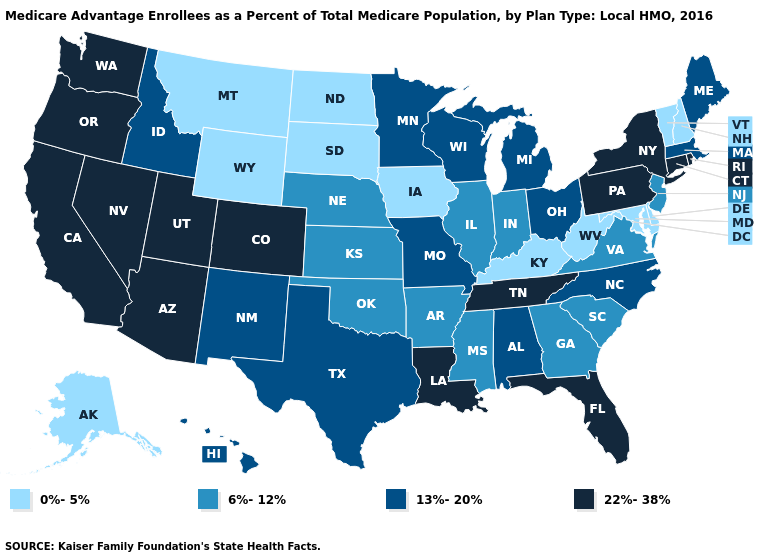What is the value of Virginia?
Concise answer only. 6%-12%. What is the highest value in the USA?
Concise answer only. 22%-38%. How many symbols are there in the legend?
Answer briefly. 4. Among the states that border Oklahoma , does New Mexico have the lowest value?
Write a very short answer. No. How many symbols are there in the legend?
Be succinct. 4. Which states have the lowest value in the Northeast?
Answer briefly. New Hampshire, Vermont. What is the value of New York?
Keep it brief. 22%-38%. Does Montana have the highest value in the West?
Short answer required. No. Does Louisiana have the highest value in the South?
Short answer required. Yes. What is the value of New Jersey?
Write a very short answer. 6%-12%. Among the states that border Maryland , does Pennsylvania have the highest value?
Short answer required. Yes. Does Georgia have a higher value than Wyoming?
Answer briefly. Yes. What is the highest value in the Northeast ?
Quick response, please. 22%-38%. What is the highest value in states that border South Carolina?
Write a very short answer. 13%-20%. Name the states that have a value in the range 22%-38%?
Write a very short answer. Arizona, California, Colorado, Connecticut, Florida, Louisiana, Nevada, New York, Oregon, Pennsylvania, Rhode Island, Tennessee, Utah, Washington. 